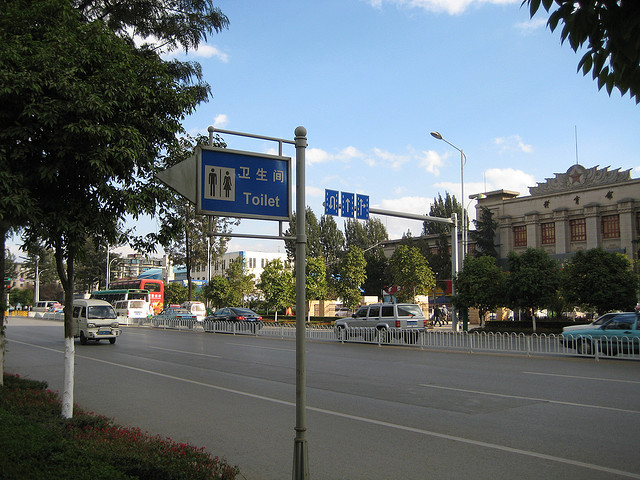Read all the text in this image. Toilet 